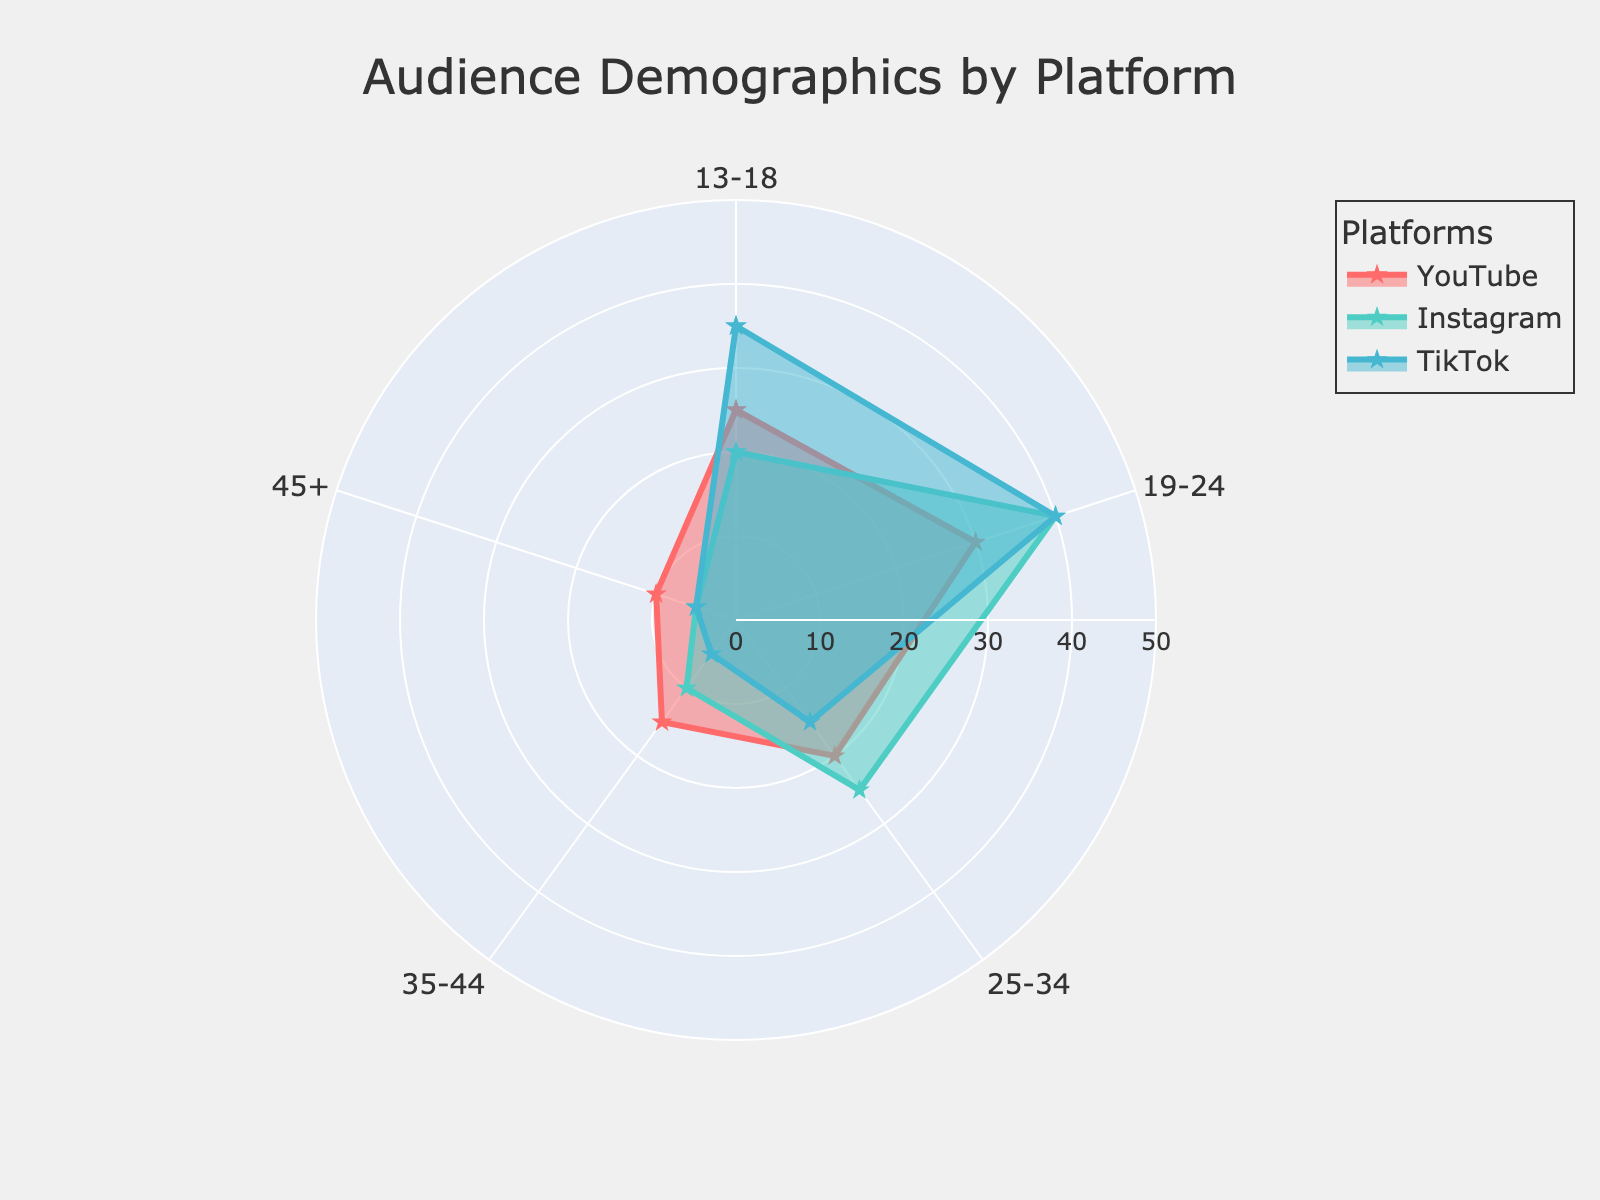Which platform has the highest proportion of users in the 19-24 age group? From the radar chart, we observe that TikTok and Instagram both have the highest percentage for the 19-24 age group at 40%.
Answer: TikTok and Instagram What is the combined percentage of users aged 25-34 across all platforms? Add the percentages for the 25-34 age group from YouTube (20%), Instagram (25%), and TikTok (15%). The total is 20 + 25 + 15 = 60%.
Answer: 60% Which age group has the smallest percentage of users on Instagram? By observing the radar chart, we see that the 45+ age group on Instagram has the smallest percentage at 5%.
Answer: 45+ How do the user percentages of the 13-18 age group compare between YouTube and TikTok? On YouTube, 25% of the audience is 13-18, while on TikTok, it is 35%. TikTok has a higher percentage for this age group.
Answer: TikTok has a higher percentage What is the most striking demographic difference between YouTube and Instagram? The largest difference is in the 19-24 age group where Instagram has 40% while YouTube has 30%.
Answer: 19-24 age group If a new music video is released, which platform might attract more viewers aged 35-44? The chart shows that the percentage of 35-44 age users is highest for YouTube at 15%, compared to 10% on Instagram and 5% on TikTok.
Answer: YouTube Which platform demonstrates the most balanced distribution of users across all age groups? By examining the radar chart, we see that Instagram has moderate percentages across all age groups, without extremely high or low values.
Answer: Instagram What is the difference in the percentage of users aged 45+ between YouTube and the other platforms? YouTube has 10% in the 45+ age group. Both Instagram and TikTok have 5%, so the difference for each is 10 - 5 = 5%.
Answer: 5% Of all the platforms, which has the greatest variation in user demographics across the age groups? TikTok has the greatest variation, with percentages ranging from the highest at 40% (19-24) to the lowest at 5% (35-44 and 45+).
Answer: TikTok 